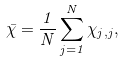Convert formula to latex. <formula><loc_0><loc_0><loc_500><loc_500>\bar { \chi } = \frac { 1 } { N } \sum _ { j = 1 } ^ { N } \chi _ { j , j } ,</formula> 